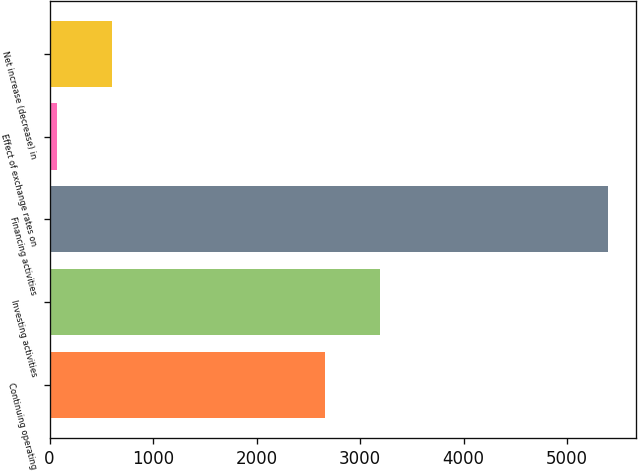Convert chart to OTSL. <chart><loc_0><loc_0><loc_500><loc_500><bar_chart><fcel>Continuing operating<fcel>Investing activities<fcel>Financing activities<fcel>Effect of exchange rates on<fcel>Net increase (decrease) in<nl><fcel>2661<fcel>3193.3<fcel>5398<fcel>75<fcel>607.3<nl></chart> 